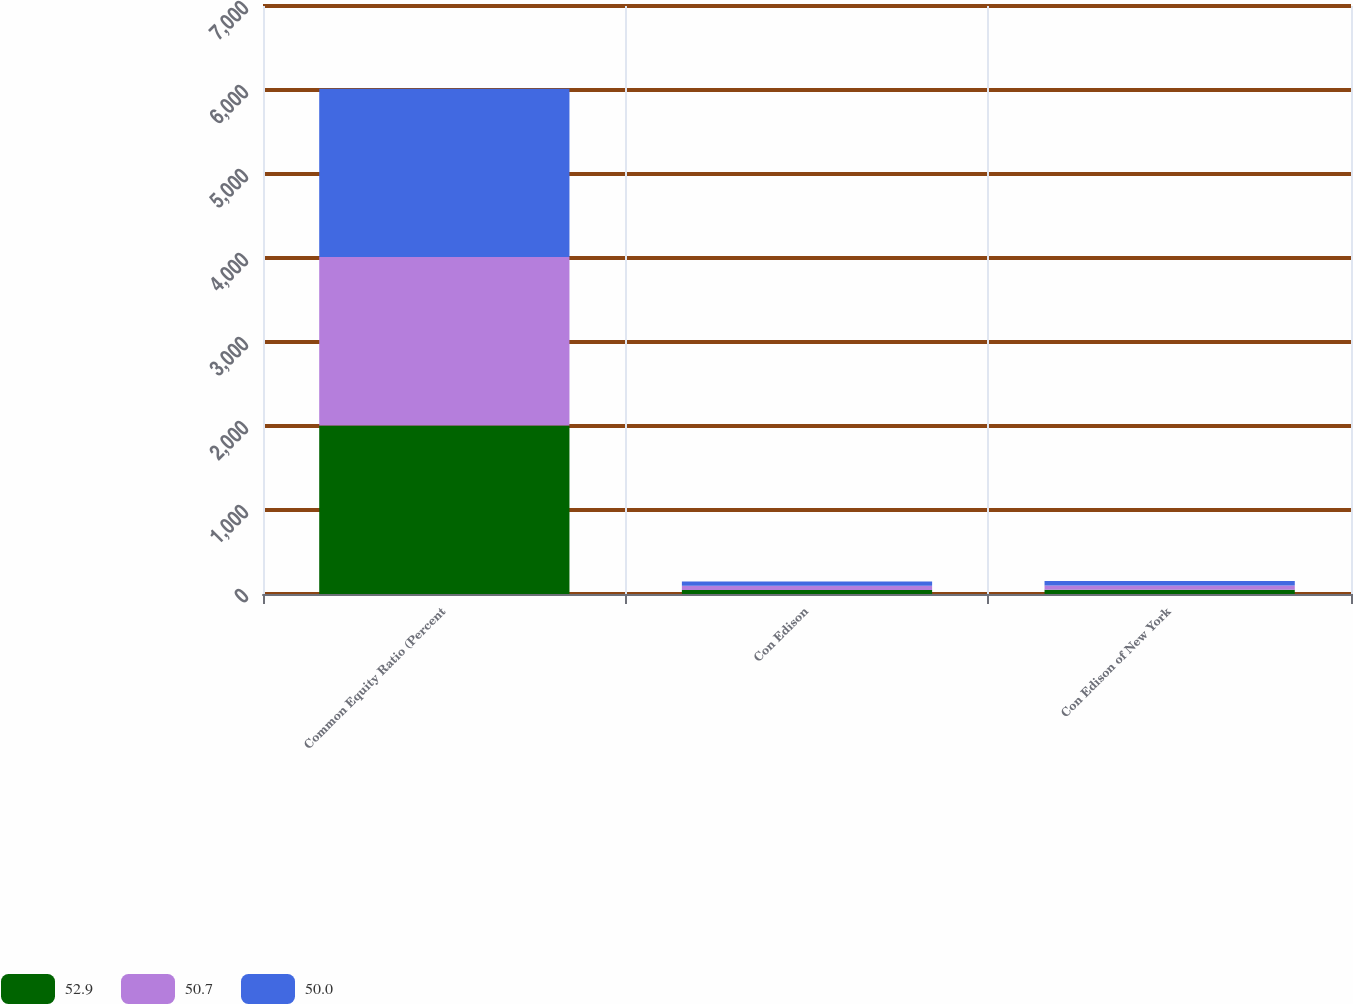<chart> <loc_0><loc_0><loc_500><loc_500><stacked_bar_chart><ecel><fcel>Common Equity Ratio (Percent<fcel>Con Edison<fcel>Con Edison of New York<nl><fcel>52.9<fcel>2006<fcel>48.5<fcel>50<nl><fcel>50.7<fcel>2005<fcel>49<fcel>50.7<nl><fcel>50<fcel>2004<fcel>51<fcel>52.9<nl></chart> 